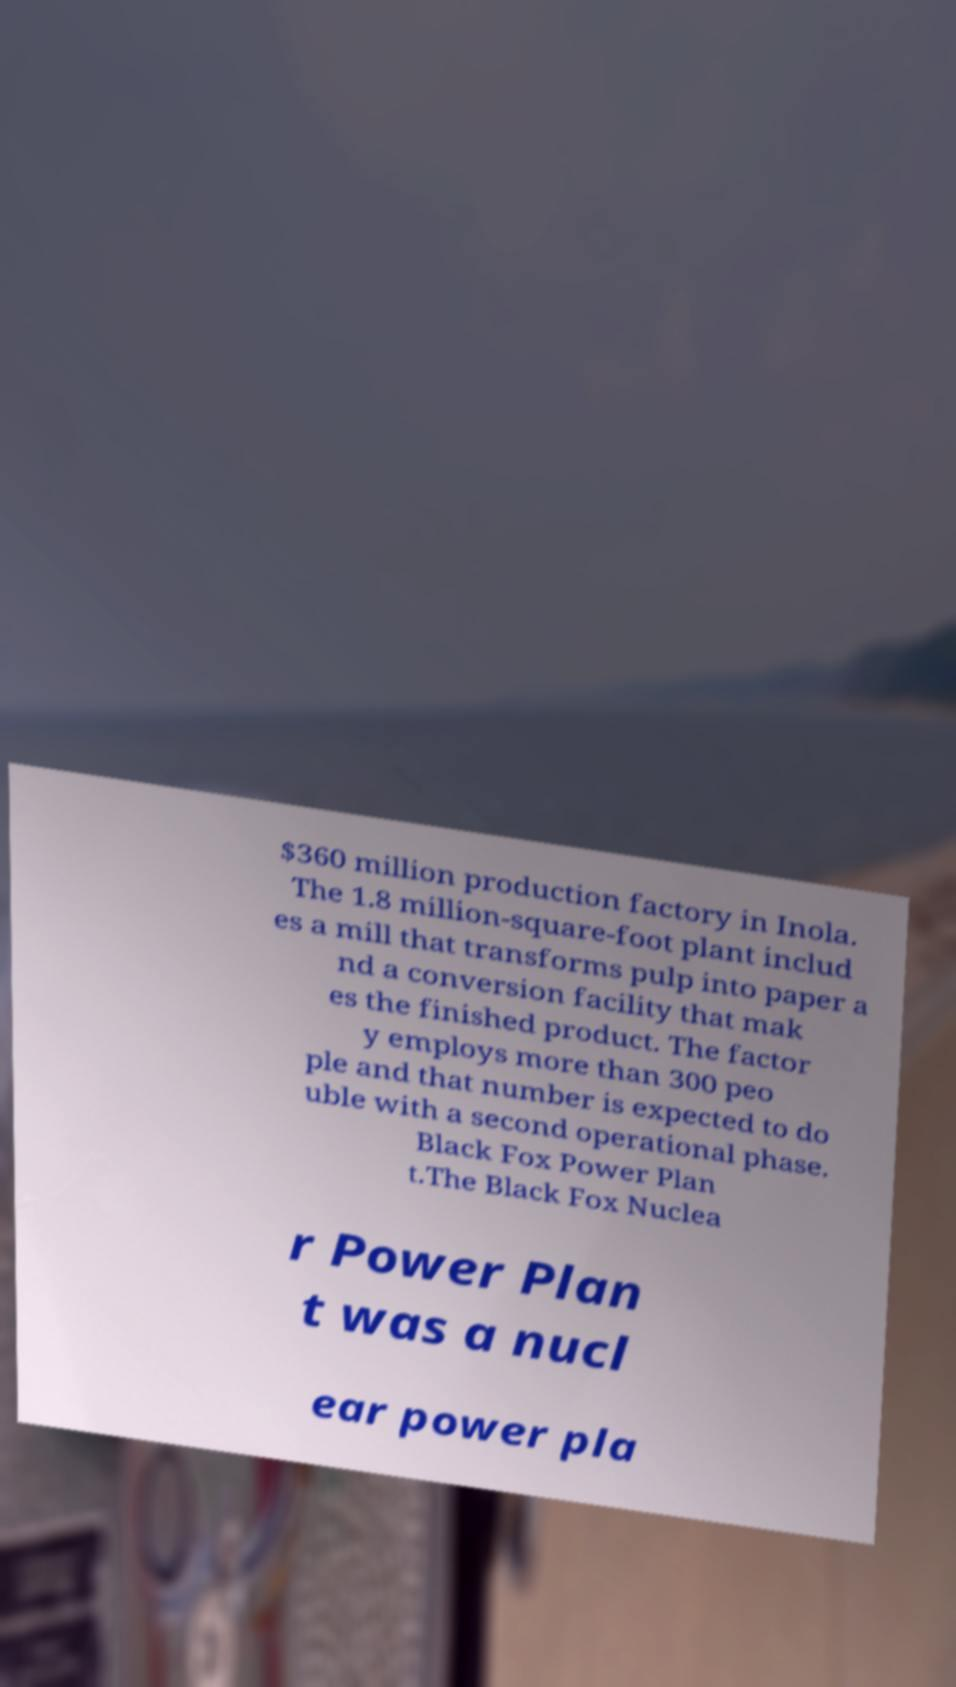What messages or text are displayed in this image? I need them in a readable, typed format. $360 million production factory in Inola. The 1.8 million-square-foot plant includ es a mill that transforms pulp into paper a nd a conversion facility that mak es the finished product. The factor y employs more than 300 peo ple and that number is expected to do uble with a second operational phase. Black Fox Power Plan t.The Black Fox Nuclea r Power Plan t was a nucl ear power pla 